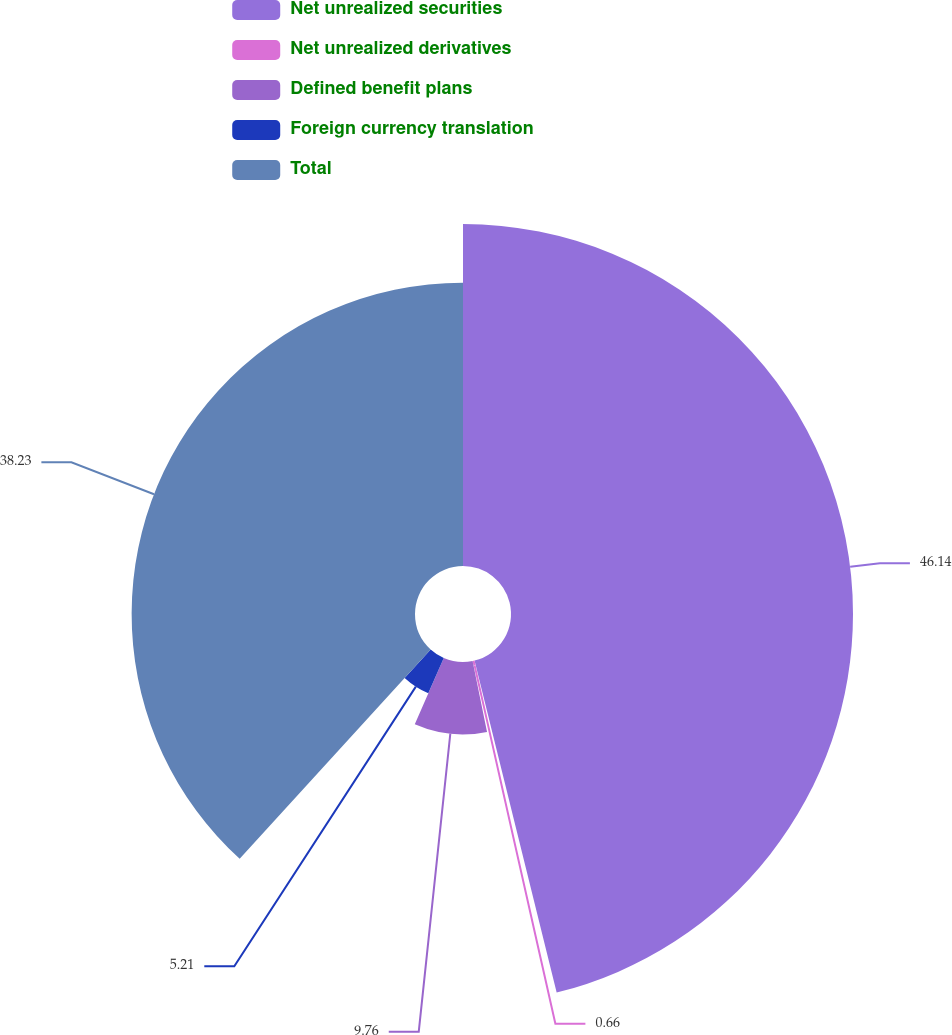Convert chart. <chart><loc_0><loc_0><loc_500><loc_500><pie_chart><fcel>Net unrealized securities<fcel>Net unrealized derivatives<fcel>Defined benefit plans<fcel>Foreign currency translation<fcel>Total<nl><fcel>46.14%<fcel>0.66%<fcel>9.76%<fcel>5.21%<fcel>38.23%<nl></chart> 